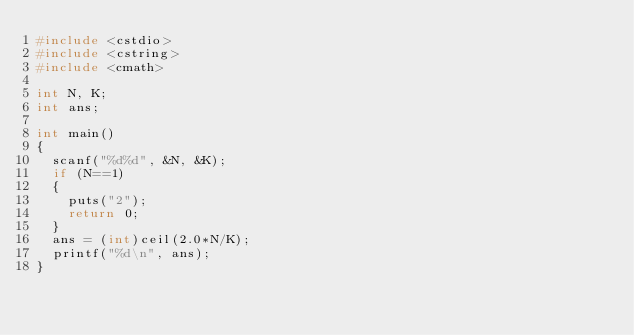Convert code to text. <code><loc_0><loc_0><loc_500><loc_500><_C++_>#include <cstdio>
#include <cstring>
#include <cmath>

int N, K;
int ans;

int main()
{
	scanf("%d%d", &N, &K);
	if (N==1)
	{
		puts("2");
		return 0;
	}
	ans = (int)ceil(2.0*N/K);
	printf("%d\n", ans);
}
</code> 